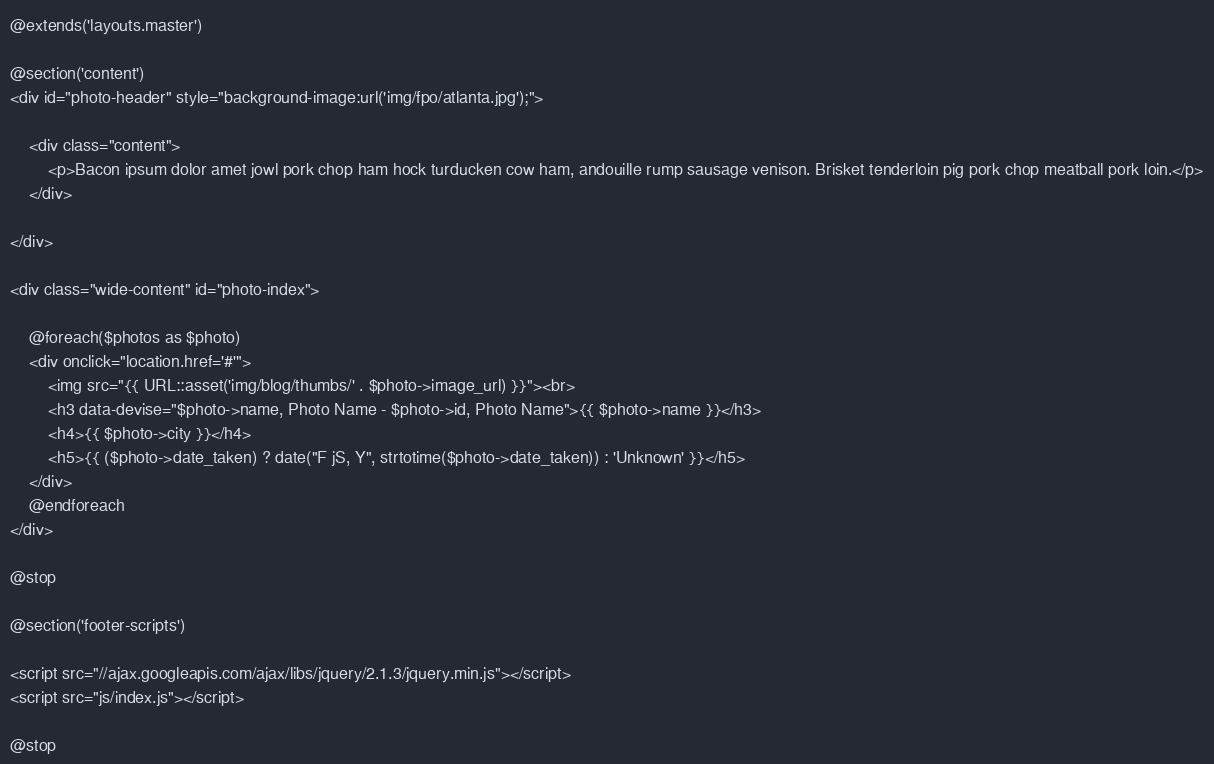Convert code to text. <code><loc_0><loc_0><loc_500><loc_500><_PHP_>@extends('layouts.master')

@section('content')
<div id="photo-header" style="background-image:url('img/fpo/atlanta.jpg');">

	<div class="content">
		<p>Bacon ipsum dolor amet jowl pork chop ham hock turducken cow ham, andouille rump sausage venison. Brisket tenderloin pig pork chop meatball pork loin.</p>
	</div>

</div>

<div class="wide-content" id="photo-index">

	@foreach($photos as $photo)
	<div onclick="location.href='#'">
		<img src="{{ URL::asset('img/blog/thumbs/' . $photo->image_url) }}"><br>
		<h3 data-devise="$photo->name, Photo Name - $photo->id, Photo Name">{{ $photo->name }}</h3>
		<h4>{{ $photo->city }}</h4>
		<h5>{{ ($photo->date_taken) ? date("F jS, Y", strtotime($photo->date_taken)) : 'Unknown' }}</h5>
	</div>
	@endforeach
</div>

@stop

@section('footer-scripts')

<script src="//ajax.googleapis.com/ajax/libs/jquery/2.1.3/jquery.min.js"></script>
<script src="js/index.js"></script>

@stop</code> 